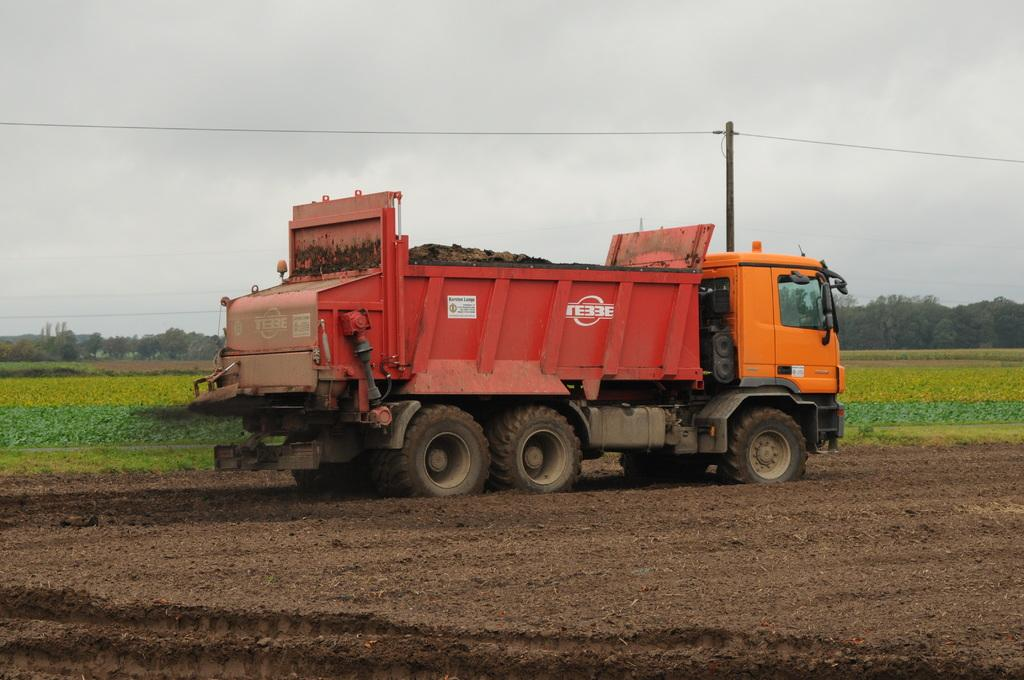What type of vehicle is on the land in the image? There is a truck on the land in the image. What can be seen behind the truck? There are crop fields behind the truck. What else is visible in the background of the image? Trees are present in the background of the image. What is visible at the top of the image? The sky is visible at the top of the image. What is connected to the wire in the image? There is a pole connected with the wire in the image. What is the taste of the heart in the image? There is no heart present in the image, so it is not possible to determine its taste. 